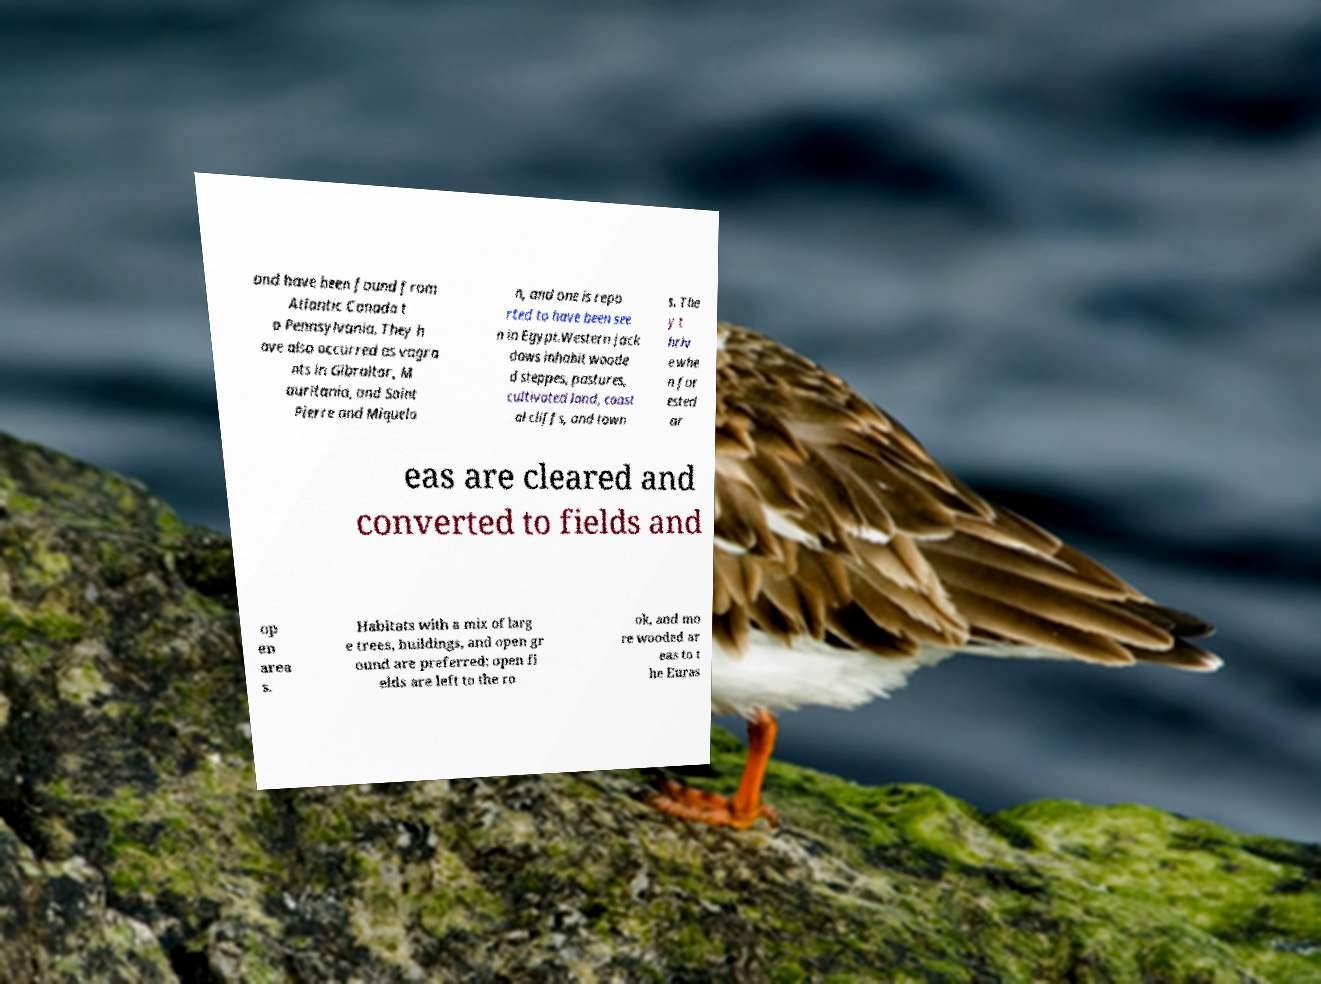I need the written content from this picture converted into text. Can you do that? and have been found from Atlantic Canada t o Pennsylvania. They h ave also occurred as vagra nts in Gibraltar, M auritania, and Saint Pierre and Miquelo n, and one is repo rted to have been see n in Egypt.Western jack daws inhabit woode d steppes, pastures, cultivated land, coast al cliffs, and town s. The y t hriv e whe n for ested ar eas are cleared and converted to fields and op en area s. Habitats with a mix of larg e trees, buildings, and open gr ound are preferred; open fi elds are left to the ro ok, and mo re wooded ar eas to t he Euras 